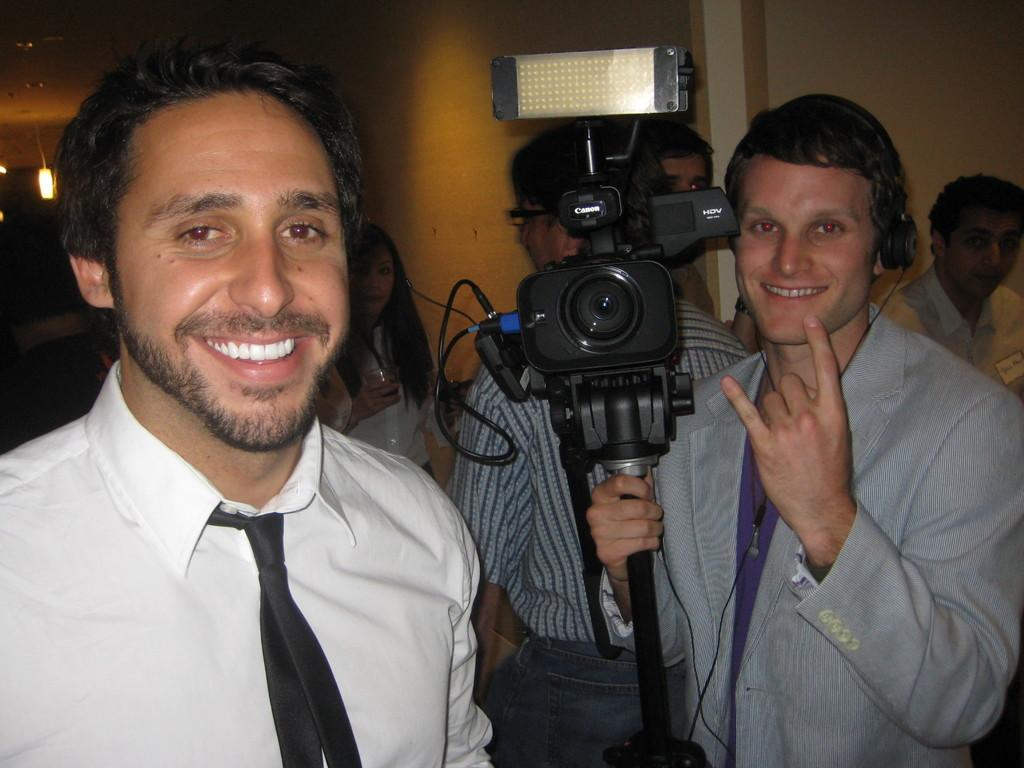How many men are present in the image? There are two men in the image. What is the facial expression of the men? Both men are smiling. What is the man on the right side holding? The man on the right side is holding a camera. Can you describe the background of the image? There are other men in the background of the image. What type of note can be seen in the hands of the man on the left side? There is no note present in the image; the man on the left side is not holding anything. What is the hearing capacity of the men in the image? There is no information about the hearing capacity of the men in the image. 